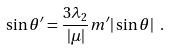Convert formula to latex. <formula><loc_0><loc_0><loc_500><loc_500>\sin { \theta ^ { \prime } } = \frac { 3 \lambda _ { 2 } } { | \mu | } m ^ { \prime } | \sin { \theta } | \ .</formula> 